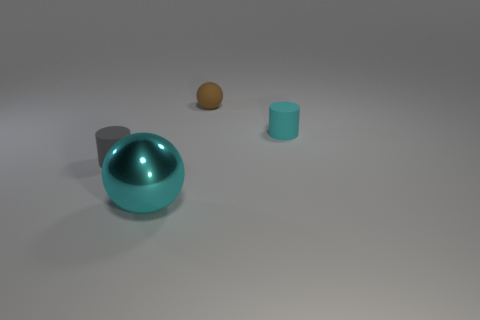Add 2 tiny cyan objects. How many objects exist? 6 Add 3 big brown shiny blocks. How many big brown shiny blocks exist? 3 Subtract 0 red cylinders. How many objects are left? 4 Subtract all cyan metallic spheres. Subtract all large cyan metal balls. How many objects are left? 2 Add 3 tiny rubber things. How many tiny rubber things are left? 6 